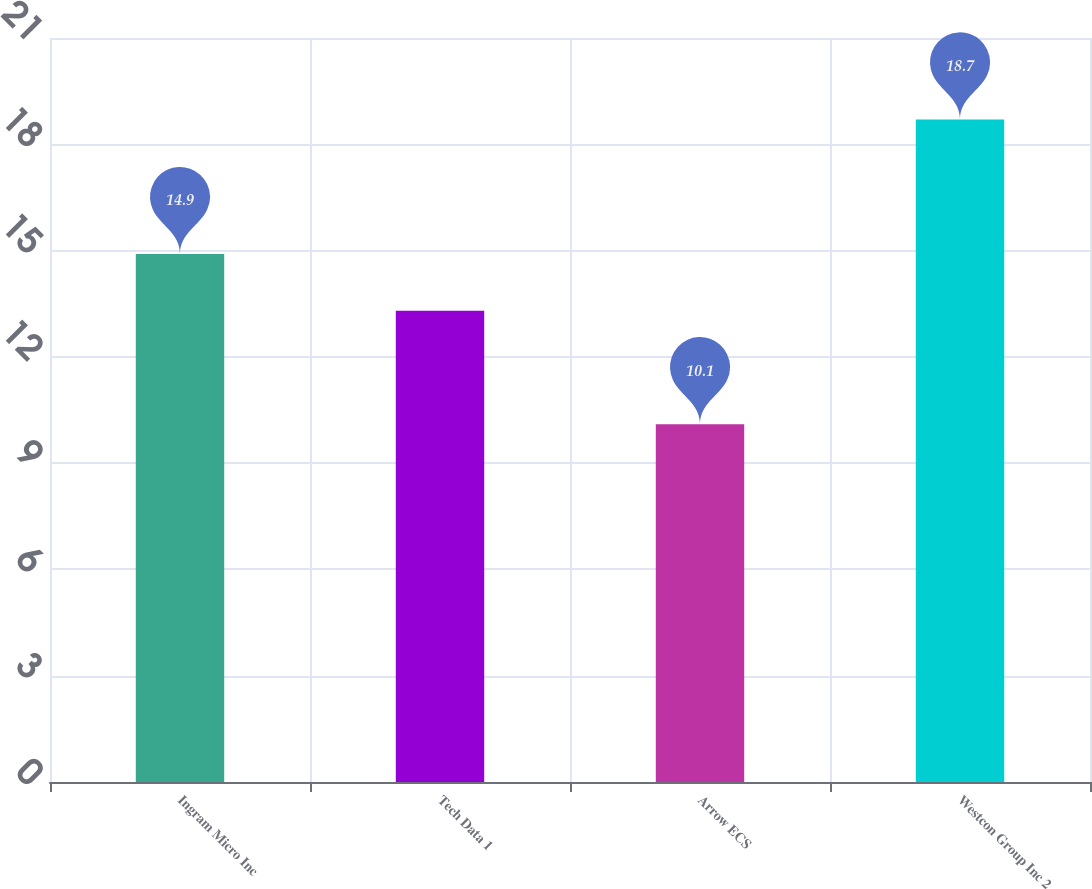Convert chart to OTSL. <chart><loc_0><loc_0><loc_500><loc_500><bar_chart><fcel>Ingram Micro Inc<fcel>Tech Data 1<fcel>Arrow ECS<fcel>Westcon Group Inc 2<nl><fcel>14.9<fcel>13.3<fcel>10.1<fcel>18.7<nl></chart> 